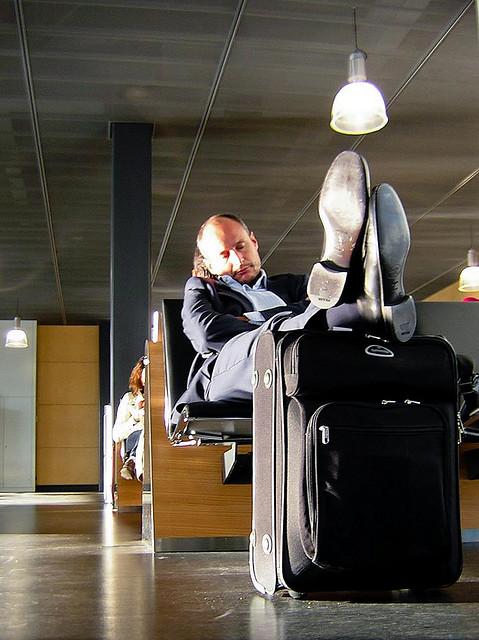Where is the man waiting?
Keep it brief. Airport. What is the man doing with his feet on the luggage?
Answer briefly. Resting. Is this a suitcase?
Short answer required. Yes. 